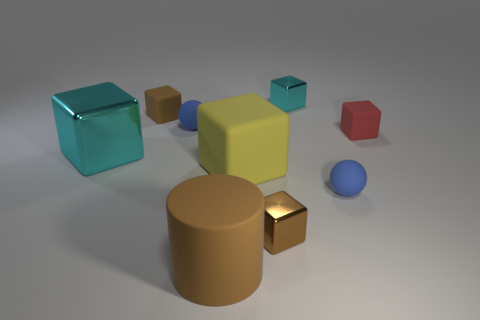Subtract all brown cubes. How many cubes are left? 4 Subtract all brown matte blocks. How many blocks are left? 5 Subtract 3 cubes. How many cubes are left? 3 Subtract all green blocks. Subtract all purple cylinders. How many blocks are left? 6 Add 1 blue objects. How many objects exist? 10 Subtract all blocks. How many objects are left? 3 Add 7 tiny brown cylinders. How many tiny brown cylinders exist? 7 Subtract 1 yellow blocks. How many objects are left? 8 Subtract all small gray things. Subtract all big brown things. How many objects are left? 8 Add 3 big yellow cubes. How many big yellow cubes are left? 4 